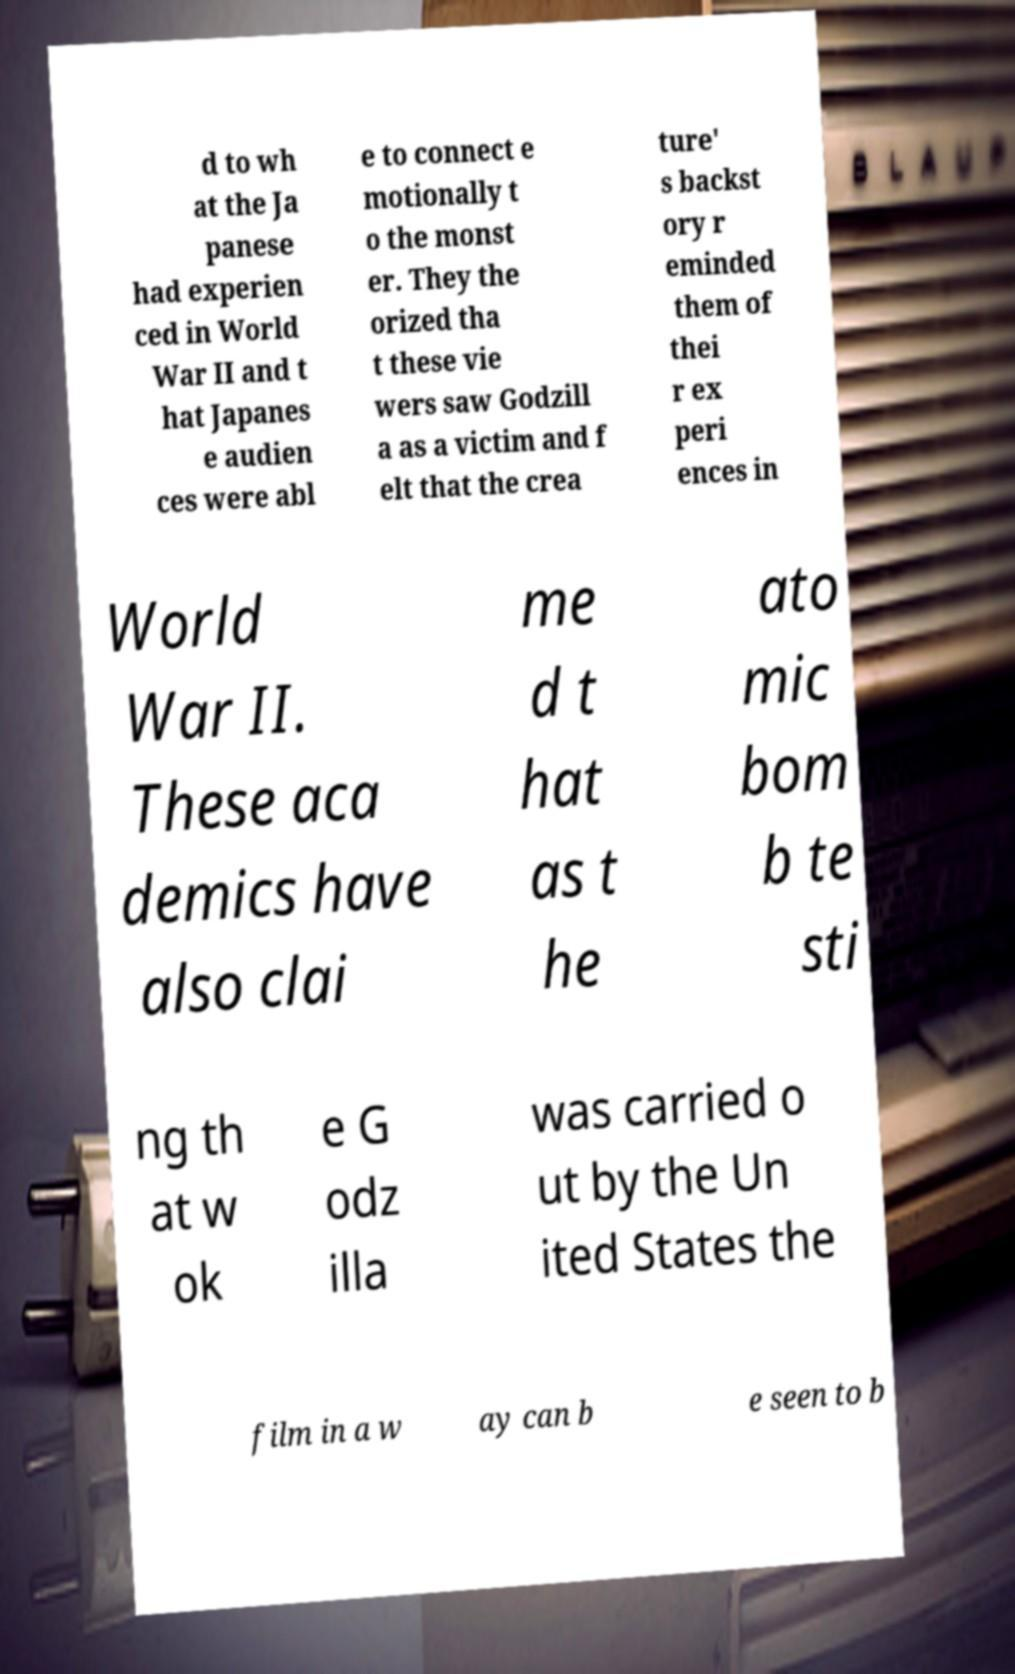I need the written content from this picture converted into text. Can you do that? d to wh at the Ja panese had experien ced in World War II and t hat Japanes e audien ces were abl e to connect e motionally t o the monst er. They the orized tha t these vie wers saw Godzill a as a victim and f elt that the crea ture' s backst ory r eminded them of thei r ex peri ences in World War II. These aca demics have also clai me d t hat as t he ato mic bom b te sti ng th at w ok e G odz illa was carried o ut by the Un ited States the film in a w ay can b e seen to b 